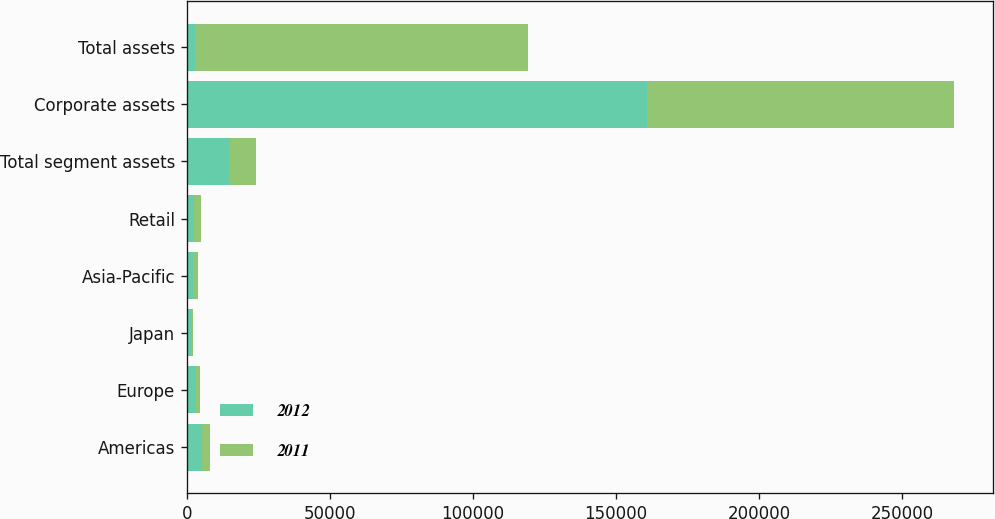Convert chart to OTSL. <chart><loc_0><loc_0><loc_500><loc_500><stacked_bar_chart><ecel><fcel>Americas<fcel>Europe<fcel>Japan<fcel>Asia-Pacific<fcel>Retail<fcel>Total segment assets<fcel>Corporate assets<fcel>Total assets<nl><fcel>2012<fcel>5525<fcel>3095<fcel>1698<fcel>2234<fcel>2725<fcel>15277<fcel>160787<fcel>2782<nl><fcel>2011<fcel>2782<fcel>1520<fcel>637<fcel>1710<fcel>2151<fcel>8800<fcel>107571<fcel>116371<nl></chart> 